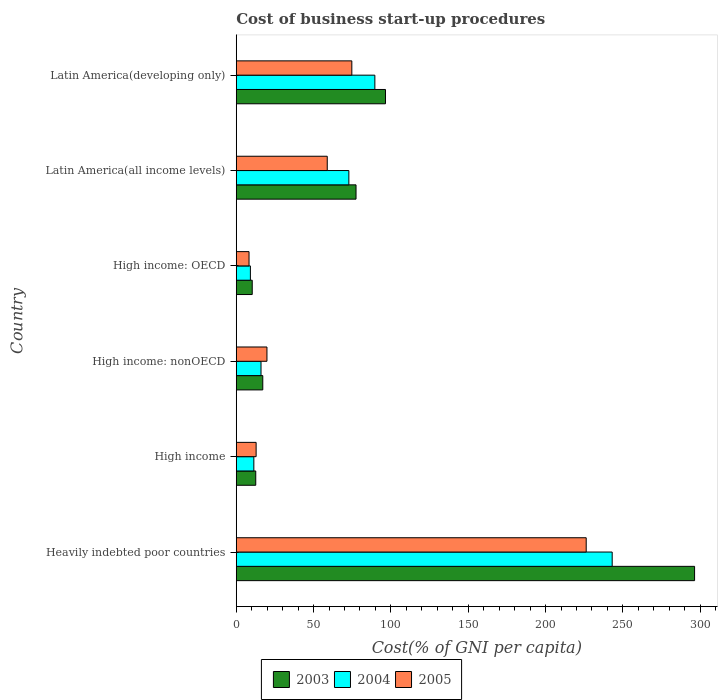How many different coloured bars are there?
Provide a short and direct response. 3. Are the number of bars per tick equal to the number of legend labels?
Provide a succinct answer. Yes. Are the number of bars on each tick of the Y-axis equal?
Your answer should be very brief. Yes. How many bars are there on the 5th tick from the top?
Your answer should be very brief. 3. How many bars are there on the 2nd tick from the bottom?
Provide a succinct answer. 3. What is the label of the 4th group of bars from the top?
Provide a succinct answer. High income: nonOECD. What is the cost of business start-up procedures in 2003 in High income: nonOECD?
Your response must be concise. 17.15. Across all countries, what is the maximum cost of business start-up procedures in 2004?
Offer a very short reply. 243.09. Across all countries, what is the minimum cost of business start-up procedures in 2003?
Provide a short and direct response. 10.33. In which country was the cost of business start-up procedures in 2004 maximum?
Provide a succinct answer. Heavily indebted poor countries. In which country was the cost of business start-up procedures in 2003 minimum?
Your answer should be very brief. High income: OECD. What is the total cost of business start-up procedures in 2004 in the graph?
Your answer should be compact. 442.05. What is the difference between the cost of business start-up procedures in 2004 in High income: OECD and that in Latin America(developing only)?
Your response must be concise. -80.49. What is the difference between the cost of business start-up procedures in 2005 in High income and the cost of business start-up procedures in 2004 in High income: nonOECD?
Your response must be concise. -3.16. What is the average cost of business start-up procedures in 2005 per country?
Give a very brief answer. 66.8. What is the difference between the cost of business start-up procedures in 2004 and cost of business start-up procedures in 2003 in High income: OECD?
Provide a short and direct response. -1.19. What is the ratio of the cost of business start-up procedures in 2005 in Heavily indebted poor countries to that in Latin America(all income levels)?
Your answer should be very brief. 3.85. Is the cost of business start-up procedures in 2003 in Latin America(all income levels) less than that in Latin America(developing only)?
Make the answer very short. Yes. What is the difference between the highest and the second highest cost of business start-up procedures in 2003?
Keep it short and to the point. 199.87. What is the difference between the highest and the lowest cost of business start-up procedures in 2005?
Provide a short and direct response. 218.02. Is the sum of the cost of business start-up procedures in 2004 in Heavily indebted poor countries and Latin America(developing only) greater than the maximum cost of business start-up procedures in 2003 across all countries?
Provide a succinct answer. Yes. What does the 2nd bar from the top in Latin America(all income levels) represents?
Offer a terse response. 2004. What does the 3rd bar from the bottom in Latin America(all income levels) represents?
Ensure brevity in your answer.  2005. Is it the case that in every country, the sum of the cost of business start-up procedures in 2003 and cost of business start-up procedures in 2005 is greater than the cost of business start-up procedures in 2004?
Your answer should be very brief. Yes. Does the graph contain any zero values?
Keep it short and to the point. No. Where does the legend appear in the graph?
Give a very brief answer. Bottom center. How many legend labels are there?
Make the answer very short. 3. How are the legend labels stacked?
Ensure brevity in your answer.  Horizontal. What is the title of the graph?
Your answer should be compact. Cost of business start-up procedures. Does "2001" appear as one of the legend labels in the graph?
Your answer should be compact. No. What is the label or title of the X-axis?
Keep it short and to the point. Cost(% of GNI per capita). What is the label or title of the Y-axis?
Your response must be concise. Country. What is the Cost(% of GNI per capita) in 2003 in Heavily indebted poor countries?
Provide a short and direct response. 296.36. What is the Cost(% of GNI per capita) of 2004 in Heavily indebted poor countries?
Offer a very short reply. 243.09. What is the Cost(% of GNI per capita) of 2005 in Heavily indebted poor countries?
Give a very brief answer. 226.29. What is the Cost(% of GNI per capita) in 2003 in High income?
Provide a short and direct response. 12.6. What is the Cost(% of GNI per capita) in 2004 in High income?
Give a very brief answer. 11.38. What is the Cost(% of GNI per capita) of 2005 in High income?
Your answer should be very brief. 12.85. What is the Cost(% of GNI per capita) of 2003 in High income: nonOECD?
Offer a terse response. 17.15. What is the Cost(% of GNI per capita) of 2004 in High income: nonOECD?
Make the answer very short. 16.01. What is the Cost(% of GNI per capita) in 2005 in High income: nonOECD?
Give a very brief answer. 19.85. What is the Cost(% of GNI per capita) in 2003 in High income: OECD?
Your answer should be very brief. 10.33. What is the Cost(% of GNI per capita) in 2004 in High income: OECD?
Your answer should be very brief. 9.14. What is the Cost(% of GNI per capita) in 2005 in High income: OECD?
Ensure brevity in your answer.  8.27. What is the Cost(% of GNI per capita) of 2003 in Latin America(all income levels)?
Give a very brief answer. 77.45. What is the Cost(% of GNI per capita) of 2004 in Latin America(all income levels)?
Your answer should be very brief. 72.81. What is the Cost(% of GNI per capita) of 2005 in Latin America(all income levels)?
Keep it short and to the point. 58.84. What is the Cost(% of GNI per capita) of 2003 in Latin America(developing only)?
Your response must be concise. 96.49. What is the Cost(% of GNI per capita) of 2004 in Latin America(developing only)?
Your answer should be very brief. 89.63. What is the Cost(% of GNI per capita) of 2005 in Latin America(developing only)?
Offer a terse response. 74.73. Across all countries, what is the maximum Cost(% of GNI per capita) of 2003?
Provide a succinct answer. 296.36. Across all countries, what is the maximum Cost(% of GNI per capita) in 2004?
Your answer should be compact. 243.09. Across all countries, what is the maximum Cost(% of GNI per capita) in 2005?
Your answer should be compact. 226.29. Across all countries, what is the minimum Cost(% of GNI per capita) of 2003?
Provide a succinct answer. 10.33. Across all countries, what is the minimum Cost(% of GNI per capita) of 2004?
Your response must be concise. 9.14. Across all countries, what is the minimum Cost(% of GNI per capita) in 2005?
Make the answer very short. 8.27. What is the total Cost(% of GNI per capita) of 2003 in the graph?
Your answer should be very brief. 510.39. What is the total Cost(% of GNI per capita) of 2004 in the graph?
Give a very brief answer. 442.05. What is the total Cost(% of GNI per capita) in 2005 in the graph?
Your response must be concise. 400.82. What is the difference between the Cost(% of GNI per capita) of 2003 in Heavily indebted poor countries and that in High income?
Your answer should be compact. 283.76. What is the difference between the Cost(% of GNI per capita) in 2004 in Heavily indebted poor countries and that in High income?
Provide a succinct answer. 231.71. What is the difference between the Cost(% of GNI per capita) of 2005 in Heavily indebted poor countries and that in High income?
Give a very brief answer. 213.44. What is the difference between the Cost(% of GNI per capita) in 2003 in Heavily indebted poor countries and that in High income: nonOECD?
Your answer should be compact. 279.21. What is the difference between the Cost(% of GNI per capita) of 2004 in Heavily indebted poor countries and that in High income: nonOECD?
Offer a very short reply. 227.08. What is the difference between the Cost(% of GNI per capita) of 2005 in Heavily indebted poor countries and that in High income: nonOECD?
Your response must be concise. 206.44. What is the difference between the Cost(% of GNI per capita) in 2003 in Heavily indebted poor countries and that in High income: OECD?
Ensure brevity in your answer.  286.03. What is the difference between the Cost(% of GNI per capita) of 2004 in Heavily indebted poor countries and that in High income: OECD?
Provide a short and direct response. 233.95. What is the difference between the Cost(% of GNI per capita) of 2005 in Heavily indebted poor countries and that in High income: OECD?
Offer a very short reply. 218.02. What is the difference between the Cost(% of GNI per capita) in 2003 in Heavily indebted poor countries and that in Latin America(all income levels)?
Offer a very short reply. 218.91. What is the difference between the Cost(% of GNI per capita) in 2004 in Heavily indebted poor countries and that in Latin America(all income levels)?
Ensure brevity in your answer.  170.28. What is the difference between the Cost(% of GNI per capita) of 2005 in Heavily indebted poor countries and that in Latin America(all income levels)?
Your response must be concise. 167.45. What is the difference between the Cost(% of GNI per capita) of 2003 in Heavily indebted poor countries and that in Latin America(developing only)?
Offer a very short reply. 199.87. What is the difference between the Cost(% of GNI per capita) of 2004 in Heavily indebted poor countries and that in Latin America(developing only)?
Your response must be concise. 153.46. What is the difference between the Cost(% of GNI per capita) of 2005 in Heavily indebted poor countries and that in Latin America(developing only)?
Offer a very short reply. 151.56. What is the difference between the Cost(% of GNI per capita) of 2003 in High income and that in High income: nonOECD?
Provide a succinct answer. -4.55. What is the difference between the Cost(% of GNI per capita) of 2004 in High income and that in High income: nonOECD?
Provide a short and direct response. -4.63. What is the difference between the Cost(% of GNI per capita) of 2005 in High income and that in High income: nonOECD?
Your response must be concise. -7. What is the difference between the Cost(% of GNI per capita) in 2003 in High income and that in High income: OECD?
Offer a terse response. 2.27. What is the difference between the Cost(% of GNI per capita) in 2004 in High income and that in High income: OECD?
Your response must be concise. 2.24. What is the difference between the Cost(% of GNI per capita) of 2005 in High income and that in High income: OECD?
Your answer should be compact. 4.58. What is the difference between the Cost(% of GNI per capita) in 2003 in High income and that in Latin America(all income levels)?
Offer a terse response. -64.85. What is the difference between the Cost(% of GNI per capita) of 2004 in High income and that in Latin America(all income levels)?
Provide a succinct answer. -61.43. What is the difference between the Cost(% of GNI per capita) of 2005 in High income and that in Latin America(all income levels)?
Offer a terse response. -45.99. What is the difference between the Cost(% of GNI per capita) in 2003 in High income and that in Latin America(developing only)?
Keep it short and to the point. -83.89. What is the difference between the Cost(% of GNI per capita) in 2004 in High income and that in Latin America(developing only)?
Make the answer very short. -78.25. What is the difference between the Cost(% of GNI per capita) in 2005 in High income and that in Latin America(developing only)?
Keep it short and to the point. -61.88. What is the difference between the Cost(% of GNI per capita) of 2003 in High income: nonOECD and that in High income: OECD?
Your answer should be compact. 6.82. What is the difference between the Cost(% of GNI per capita) in 2004 in High income: nonOECD and that in High income: OECD?
Make the answer very short. 6.87. What is the difference between the Cost(% of GNI per capita) of 2005 in High income: nonOECD and that in High income: OECD?
Ensure brevity in your answer.  11.58. What is the difference between the Cost(% of GNI per capita) of 2003 in High income: nonOECD and that in Latin America(all income levels)?
Provide a short and direct response. -60.3. What is the difference between the Cost(% of GNI per capita) of 2004 in High income: nonOECD and that in Latin America(all income levels)?
Make the answer very short. -56.8. What is the difference between the Cost(% of GNI per capita) in 2005 in High income: nonOECD and that in Latin America(all income levels)?
Your response must be concise. -38.99. What is the difference between the Cost(% of GNI per capita) of 2003 in High income: nonOECD and that in Latin America(developing only)?
Provide a short and direct response. -79.34. What is the difference between the Cost(% of GNI per capita) in 2004 in High income: nonOECD and that in Latin America(developing only)?
Ensure brevity in your answer.  -73.62. What is the difference between the Cost(% of GNI per capita) in 2005 in High income: nonOECD and that in Latin America(developing only)?
Ensure brevity in your answer.  -54.88. What is the difference between the Cost(% of GNI per capita) in 2003 in High income: OECD and that in Latin America(all income levels)?
Provide a succinct answer. -67.12. What is the difference between the Cost(% of GNI per capita) of 2004 in High income: OECD and that in Latin America(all income levels)?
Provide a succinct answer. -63.67. What is the difference between the Cost(% of GNI per capita) of 2005 in High income: OECD and that in Latin America(all income levels)?
Provide a short and direct response. -50.58. What is the difference between the Cost(% of GNI per capita) of 2003 in High income: OECD and that in Latin America(developing only)?
Keep it short and to the point. -86.16. What is the difference between the Cost(% of GNI per capita) of 2004 in High income: OECD and that in Latin America(developing only)?
Ensure brevity in your answer.  -80.49. What is the difference between the Cost(% of GNI per capita) in 2005 in High income: OECD and that in Latin America(developing only)?
Your answer should be compact. -66.46. What is the difference between the Cost(% of GNI per capita) of 2003 in Latin America(all income levels) and that in Latin America(developing only)?
Your response must be concise. -19.04. What is the difference between the Cost(% of GNI per capita) of 2004 in Latin America(all income levels) and that in Latin America(developing only)?
Make the answer very short. -16.82. What is the difference between the Cost(% of GNI per capita) of 2005 in Latin America(all income levels) and that in Latin America(developing only)?
Your answer should be very brief. -15.89. What is the difference between the Cost(% of GNI per capita) in 2003 in Heavily indebted poor countries and the Cost(% of GNI per capita) in 2004 in High income?
Ensure brevity in your answer.  284.99. What is the difference between the Cost(% of GNI per capita) of 2003 in Heavily indebted poor countries and the Cost(% of GNI per capita) of 2005 in High income?
Your answer should be compact. 283.51. What is the difference between the Cost(% of GNI per capita) in 2004 in Heavily indebted poor countries and the Cost(% of GNI per capita) in 2005 in High income?
Offer a very short reply. 230.24. What is the difference between the Cost(% of GNI per capita) of 2003 in Heavily indebted poor countries and the Cost(% of GNI per capita) of 2004 in High income: nonOECD?
Keep it short and to the point. 280.35. What is the difference between the Cost(% of GNI per capita) in 2003 in Heavily indebted poor countries and the Cost(% of GNI per capita) in 2005 in High income: nonOECD?
Keep it short and to the point. 276.51. What is the difference between the Cost(% of GNI per capita) in 2004 in Heavily indebted poor countries and the Cost(% of GNI per capita) in 2005 in High income: nonOECD?
Provide a short and direct response. 223.24. What is the difference between the Cost(% of GNI per capita) in 2003 in Heavily indebted poor countries and the Cost(% of GNI per capita) in 2004 in High income: OECD?
Ensure brevity in your answer.  287.22. What is the difference between the Cost(% of GNI per capita) in 2003 in Heavily indebted poor countries and the Cost(% of GNI per capita) in 2005 in High income: OECD?
Your answer should be compact. 288.1. What is the difference between the Cost(% of GNI per capita) in 2004 in Heavily indebted poor countries and the Cost(% of GNI per capita) in 2005 in High income: OECD?
Provide a succinct answer. 234.82. What is the difference between the Cost(% of GNI per capita) of 2003 in Heavily indebted poor countries and the Cost(% of GNI per capita) of 2004 in Latin America(all income levels)?
Give a very brief answer. 223.55. What is the difference between the Cost(% of GNI per capita) of 2003 in Heavily indebted poor countries and the Cost(% of GNI per capita) of 2005 in Latin America(all income levels)?
Your answer should be compact. 237.52. What is the difference between the Cost(% of GNI per capita) in 2004 in Heavily indebted poor countries and the Cost(% of GNI per capita) in 2005 in Latin America(all income levels)?
Your response must be concise. 184.25. What is the difference between the Cost(% of GNI per capita) in 2003 in Heavily indebted poor countries and the Cost(% of GNI per capita) in 2004 in Latin America(developing only)?
Your response must be concise. 206.74. What is the difference between the Cost(% of GNI per capita) of 2003 in Heavily indebted poor countries and the Cost(% of GNI per capita) of 2005 in Latin America(developing only)?
Make the answer very short. 221.63. What is the difference between the Cost(% of GNI per capita) of 2004 in Heavily indebted poor countries and the Cost(% of GNI per capita) of 2005 in Latin America(developing only)?
Ensure brevity in your answer.  168.36. What is the difference between the Cost(% of GNI per capita) in 2003 in High income and the Cost(% of GNI per capita) in 2004 in High income: nonOECD?
Your answer should be compact. -3.4. What is the difference between the Cost(% of GNI per capita) in 2003 in High income and the Cost(% of GNI per capita) in 2005 in High income: nonOECD?
Offer a very short reply. -7.24. What is the difference between the Cost(% of GNI per capita) of 2004 in High income and the Cost(% of GNI per capita) of 2005 in High income: nonOECD?
Your answer should be compact. -8.47. What is the difference between the Cost(% of GNI per capita) of 2003 in High income and the Cost(% of GNI per capita) of 2004 in High income: OECD?
Your answer should be very brief. 3.46. What is the difference between the Cost(% of GNI per capita) in 2003 in High income and the Cost(% of GNI per capita) in 2005 in High income: OECD?
Provide a short and direct response. 4.34. What is the difference between the Cost(% of GNI per capita) of 2004 in High income and the Cost(% of GNI per capita) of 2005 in High income: OECD?
Offer a terse response. 3.11. What is the difference between the Cost(% of GNI per capita) in 2003 in High income and the Cost(% of GNI per capita) in 2004 in Latin America(all income levels)?
Ensure brevity in your answer.  -60.21. What is the difference between the Cost(% of GNI per capita) of 2003 in High income and the Cost(% of GNI per capita) of 2005 in Latin America(all income levels)?
Your answer should be very brief. -46.24. What is the difference between the Cost(% of GNI per capita) of 2004 in High income and the Cost(% of GNI per capita) of 2005 in Latin America(all income levels)?
Offer a very short reply. -47.46. What is the difference between the Cost(% of GNI per capita) in 2003 in High income and the Cost(% of GNI per capita) in 2004 in Latin America(developing only)?
Your answer should be compact. -77.02. What is the difference between the Cost(% of GNI per capita) of 2003 in High income and the Cost(% of GNI per capita) of 2005 in Latin America(developing only)?
Give a very brief answer. -62.12. What is the difference between the Cost(% of GNI per capita) of 2004 in High income and the Cost(% of GNI per capita) of 2005 in Latin America(developing only)?
Your answer should be very brief. -63.35. What is the difference between the Cost(% of GNI per capita) of 2003 in High income: nonOECD and the Cost(% of GNI per capita) of 2004 in High income: OECD?
Give a very brief answer. 8.01. What is the difference between the Cost(% of GNI per capita) of 2003 in High income: nonOECD and the Cost(% of GNI per capita) of 2005 in High income: OECD?
Keep it short and to the point. 8.88. What is the difference between the Cost(% of GNI per capita) in 2004 in High income: nonOECD and the Cost(% of GNI per capita) in 2005 in High income: OECD?
Your answer should be compact. 7.74. What is the difference between the Cost(% of GNI per capita) in 2003 in High income: nonOECD and the Cost(% of GNI per capita) in 2004 in Latin America(all income levels)?
Your answer should be very brief. -55.66. What is the difference between the Cost(% of GNI per capita) of 2003 in High income: nonOECD and the Cost(% of GNI per capita) of 2005 in Latin America(all income levels)?
Offer a very short reply. -41.69. What is the difference between the Cost(% of GNI per capita) of 2004 in High income: nonOECD and the Cost(% of GNI per capita) of 2005 in Latin America(all income levels)?
Your response must be concise. -42.83. What is the difference between the Cost(% of GNI per capita) of 2003 in High income: nonOECD and the Cost(% of GNI per capita) of 2004 in Latin America(developing only)?
Offer a terse response. -72.48. What is the difference between the Cost(% of GNI per capita) of 2003 in High income: nonOECD and the Cost(% of GNI per capita) of 2005 in Latin America(developing only)?
Provide a succinct answer. -57.58. What is the difference between the Cost(% of GNI per capita) in 2004 in High income: nonOECD and the Cost(% of GNI per capita) in 2005 in Latin America(developing only)?
Offer a terse response. -58.72. What is the difference between the Cost(% of GNI per capita) of 2003 in High income: OECD and the Cost(% of GNI per capita) of 2004 in Latin America(all income levels)?
Give a very brief answer. -62.48. What is the difference between the Cost(% of GNI per capita) of 2003 in High income: OECD and the Cost(% of GNI per capita) of 2005 in Latin America(all income levels)?
Give a very brief answer. -48.51. What is the difference between the Cost(% of GNI per capita) of 2004 in High income: OECD and the Cost(% of GNI per capita) of 2005 in Latin America(all income levels)?
Make the answer very short. -49.7. What is the difference between the Cost(% of GNI per capita) of 2003 in High income: OECD and the Cost(% of GNI per capita) of 2004 in Latin America(developing only)?
Give a very brief answer. -79.29. What is the difference between the Cost(% of GNI per capita) of 2003 in High income: OECD and the Cost(% of GNI per capita) of 2005 in Latin America(developing only)?
Offer a terse response. -64.4. What is the difference between the Cost(% of GNI per capita) in 2004 in High income: OECD and the Cost(% of GNI per capita) in 2005 in Latin America(developing only)?
Make the answer very short. -65.59. What is the difference between the Cost(% of GNI per capita) of 2003 in Latin America(all income levels) and the Cost(% of GNI per capita) of 2004 in Latin America(developing only)?
Give a very brief answer. -12.17. What is the difference between the Cost(% of GNI per capita) of 2003 in Latin America(all income levels) and the Cost(% of GNI per capita) of 2005 in Latin America(developing only)?
Your answer should be very brief. 2.72. What is the difference between the Cost(% of GNI per capita) of 2004 in Latin America(all income levels) and the Cost(% of GNI per capita) of 2005 in Latin America(developing only)?
Offer a very short reply. -1.92. What is the average Cost(% of GNI per capita) in 2003 per country?
Provide a succinct answer. 85.07. What is the average Cost(% of GNI per capita) of 2004 per country?
Your response must be concise. 73.67. What is the average Cost(% of GNI per capita) of 2005 per country?
Offer a very short reply. 66.8. What is the difference between the Cost(% of GNI per capita) in 2003 and Cost(% of GNI per capita) in 2004 in Heavily indebted poor countries?
Offer a terse response. 53.27. What is the difference between the Cost(% of GNI per capita) of 2003 and Cost(% of GNI per capita) of 2005 in Heavily indebted poor countries?
Your answer should be compact. 70.08. What is the difference between the Cost(% of GNI per capita) of 2004 and Cost(% of GNI per capita) of 2005 in Heavily indebted poor countries?
Give a very brief answer. 16.8. What is the difference between the Cost(% of GNI per capita) in 2003 and Cost(% of GNI per capita) in 2004 in High income?
Make the answer very short. 1.23. What is the difference between the Cost(% of GNI per capita) of 2003 and Cost(% of GNI per capita) of 2005 in High income?
Make the answer very short. -0.25. What is the difference between the Cost(% of GNI per capita) in 2004 and Cost(% of GNI per capita) in 2005 in High income?
Your answer should be very brief. -1.47. What is the difference between the Cost(% of GNI per capita) in 2003 and Cost(% of GNI per capita) in 2005 in High income: nonOECD?
Offer a very short reply. -2.7. What is the difference between the Cost(% of GNI per capita) in 2004 and Cost(% of GNI per capita) in 2005 in High income: nonOECD?
Offer a terse response. -3.84. What is the difference between the Cost(% of GNI per capita) in 2003 and Cost(% of GNI per capita) in 2004 in High income: OECD?
Provide a succinct answer. 1.19. What is the difference between the Cost(% of GNI per capita) of 2003 and Cost(% of GNI per capita) of 2005 in High income: OECD?
Provide a short and direct response. 2.07. What is the difference between the Cost(% of GNI per capita) of 2004 and Cost(% of GNI per capita) of 2005 in High income: OECD?
Your answer should be compact. 0.88. What is the difference between the Cost(% of GNI per capita) in 2003 and Cost(% of GNI per capita) in 2004 in Latin America(all income levels)?
Keep it short and to the point. 4.64. What is the difference between the Cost(% of GNI per capita) in 2003 and Cost(% of GNI per capita) in 2005 in Latin America(all income levels)?
Your answer should be compact. 18.61. What is the difference between the Cost(% of GNI per capita) in 2004 and Cost(% of GNI per capita) in 2005 in Latin America(all income levels)?
Offer a terse response. 13.97. What is the difference between the Cost(% of GNI per capita) of 2003 and Cost(% of GNI per capita) of 2004 in Latin America(developing only)?
Offer a very short reply. 6.87. What is the difference between the Cost(% of GNI per capita) of 2003 and Cost(% of GNI per capita) of 2005 in Latin America(developing only)?
Provide a short and direct response. 21.76. What is the difference between the Cost(% of GNI per capita) of 2004 and Cost(% of GNI per capita) of 2005 in Latin America(developing only)?
Make the answer very short. 14.9. What is the ratio of the Cost(% of GNI per capita) in 2003 in Heavily indebted poor countries to that in High income?
Offer a very short reply. 23.51. What is the ratio of the Cost(% of GNI per capita) in 2004 in Heavily indebted poor countries to that in High income?
Provide a succinct answer. 21.37. What is the ratio of the Cost(% of GNI per capita) in 2005 in Heavily indebted poor countries to that in High income?
Offer a very short reply. 17.61. What is the ratio of the Cost(% of GNI per capita) in 2003 in Heavily indebted poor countries to that in High income: nonOECD?
Keep it short and to the point. 17.28. What is the ratio of the Cost(% of GNI per capita) of 2004 in Heavily indebted poor countries to that in High income: nonOECD?
Ensure brevity in your answer.  15.19. What is the ratio of the Cost(% of GNI per capita) of 2005 in Heavily indebted poor countries to that in High income: nonOECD?
Offer a very short reply. 11.4. What is the ratio of the Cost(% of GNI per capita) of 2003 in Heavily indebted poor countries to that in High income: OECD?
Give a very brief answer. 28.68. What is the ratio of the Cost(% of GNI per capita) in 2004 in Heavily indebted poor countries to that in High income: OECD?
Make the answer very short. 26.59. What is the ratio of the Cost(% of GNI per capita) in 2005 in Heavily indebted poor countries to that in High income: OECD?
Your answer should be very brief. 27.38. What is the ratio of the Cost(% of GNI per capita) of 2003 in Heavily indebted poor countries to that in Latin America(all income levels)?
Give a very brief answer. 3.83. What is the ratio of the Cost(% of GNI per capita) in 2004 in Heavily indebted poor countries to that in Latin America(all income levels)?
Ensure brevity in your answer.  3.34. What is the ratio of the Cost(% of GNI per capita) of 2005 in Heavily indebted poor countries to that in Latin America(all income levels)?
Provide a short and direct response. 3.85. What is the ratio of the Cost(% of GNI per capita) of 2003 in Heavily indebted poor countries to that in Latin America(developing only)?
Offer a very short reply. 3.07. What is the ratio of the Cost(% of GNI per capita) of 2004 in Heavily indebted poor countries to that in Latin America(developing only)?
Your answer should be very brief. 2.71. What is the ratio of the Cost(% of GNI per capita) in 2005 in Heavily indebted poor countries to that in Latin America(developing only)?
Your response must be concise. 3.03. What is the ratio of the Cost(% of GNI per capita) in 2003 in High income to that in High income: nonOECD?
Provide a short and direct response. 0.73. What is the ratio of the Cost(% of GNI per capita) of 2004 in High income to that in High income: nonOECD?
Your answer should be very brief. 0.71. What is the ratio of the Cost(% of GNI per capita) in 2005 in High income to that in High income: nonOECD?
Ensure brevity in your answer.  0.65. What is the ratio of the Cost(% of GNI per capita) in 2003 in High income to that in High income: OECD?
Make the answer very short. 1.22. What is the ratio of the Cost(% of GNI per capita) in 2004 in High income to that in High income: OECD?
Your answer should be very brief. 1.24. What is the ratio of the Cost(% of GNI per capita) of 2005 in High income to that in High income: OECD?
Your answer should be compact. 1.55. What is the ratio of the Cost(% of GNI per capita) in 2003 in High income to that in Latin America(all income levels)?
Your answer should be compact. 0.16. What is the ratio of the Cost(% of GNI per capita) of 2004 in High income to that in Latin America(all income levels)?
Provide a short and direct response. 0.16. What is the ratio of the Cost(% of GNI per capita) of 2005 in High income to that in Latin America(all income levels)?
Your answer should be very brief. 0.22. What is the ratio of the Cost(% of GNI per capita) in 2003 in High income to that in Latin America(developing only)?
Provide a short and direct response. 0.13. What is the ratio of the Cost(% of GNI per capita) of 2004 in High income to that in Latin America(developing only)?
Your response must be concise. 0.13. What is the ratio of the Cost(% of GNI per capita) in 2005 in High income to that in Latin America(developing only)?
Your answer should be compact. 0.17. What is the ratio of the Cost(% of GNI per capita) in 2003 in High income: nonOECD to that in High income: OECD?
Keep it short and to the point. 1.66. What is the ratio of the Cost(% of GNI per capita) of 2004 in High income: nonOECD to that in High income: OECD?
Provide a succinct answer. 1.75. What is the ratio of the Cost(% of GNI per capita) in 2005 in High income: nonOECD to that in High income: OECD?
Offer a terse response. 2.4. What is the ratio of the Cost(% of GNI per capita) in 2003 in High income: nonOECD to that in Latin America(all income levels)?
Keep it short and to the point. 0.22. What is the ratio of the Cost(% of GNI per capita) in 2004 in High income: nonOECD to that in Latin America(all income levels)?
Ensure brevity in your answer.  0.22. What is the ratio of the Cost(% of GNI per capita) of 2005 in High income: nonOECD to that in Latin America(all income levels)?
Make the answer very short. 0.34. What is the ratio of the Cost(% of GNI per capita) in 2003 in High income: nonOECD to that in Latin America(developing only)?
Offer a terse response. 0.18. What is the ratio of the Cost(% of GNI per capita) in 2004 in High income: nonOECD to that in Latin America(developing only)?
Your response must be concise. 0.18. What is the ratio of the Cost(% of GNI per capita) in 2005 in High income: nonOECD to that in Latin America(developing only)?
Make the answer very short. 0.27. What is the ratio of the Cost(% of GNI per capita) in 2003 in High income: OECD to that in Latin America(all income levels)?
Your response must be concise. 0.13. What is the ratio of the Cost(% of GNI per capita) of 2004 in High income: OECD to that in Latin America(all income levels)?
Your answer should be compact. 0.13. What is the ratio of the Cost(% of GNI per capita) of 2005 in High income: OECD to that in Latin America(all income levels)?
Ensure brevity in your answer.  0.14. What is the ratio of the Cost(% of GNI per capita) of 2003 in High income: OECD to that in Latin America(developing only)?
Offer a very short reply. 0.11. What is the ratio of the Cost(% of GNI per capita) of 2004 in High income: OECD to that in Latin America(developing only)?
Provide a short and direct response. 0.1. What is the ratio of the Cost(% of GNI per capita) in 2005 in High income: OECD to that in Latin America(developing only)?
Offer a very short reply. 0.11. What is the ratio of the Cost(% of GNI per capita) of 2003 in Latin America(all income levels) to that in Latin America(developing only)?
Give a very brief answer. 0.8. What is the ratio of the Cost(% of GNI per capita) in 2004 in Latin America(all income levels) to that in Latin America(developing only)?
Your answer should be very brief. 0.81. What is the ratio of the Cost(% of GNI per capita) of 2005 in Latin America(all income levels) to that in Latin America(developing only)?
Your response must be concise. 0.79. What is the difference between the highest and the second highest Cost(% of GNI per capita) of 2003?
Your response must be concise. 199.87. What is the difference between the highest and the second highest Cost(% of GNI per capita) in 2004?
Keep it short and to the point. 153.46. What is the difference between the highest and the second highest Cost(% of GNI per capita) in 2005?
Your answer should be very brief. 151.56. What is the difference between the highest and the lowest Cost(% of GNI per capita) of 2003?
Your answer should be very brief. 286.03. What is the difference between the highest and the lowest Cost(% of GNI per capita) of 2004?
Offer a very short reply. 233.95. What is the difference between the highest and the lowest Cost(% of GNI per capita) of 2005?
Your response must be concise. 218.02. 